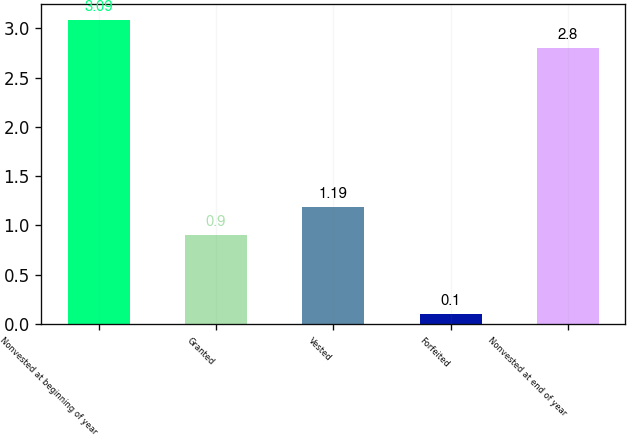Convert chart. <chart><loc_0><loc_0><loc_500><loc_500><bar_chart><fcel>Nonvested at beginning of year<fcel>Granted<fcel>Vested<fcel>Forfeited<fcel>Nonvested at end of year<nl><fcel>3.09<fcel>0.9<fcel>1.19<fcel>0.1<fcel>2.8<nl></chart> 